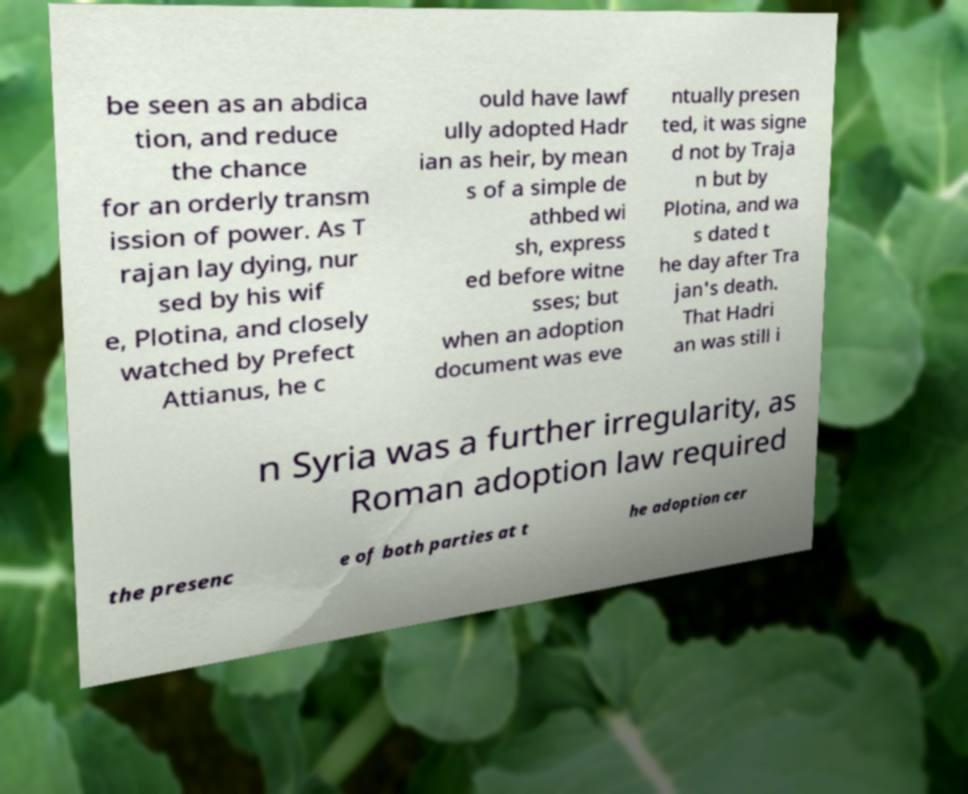Can you accurately transcribe the text from the provided image for me? be seen as an abdica tion, and reduce the chance for an orderly transm ission of power. As T rajan lay dying, nur sed by his wif e, Plotina, and closely watched by Prefect Attianus, he c ould have lawf ully adopted Hadr ian as heir, by mean s of a simple de athbed wi sh, express ed before witne sses; but when an adoption document was eve ntually presen ted, it was signe d not by Traja n but by Plotina, and wa s dated t he day after Tra jan's death. That Hadri an was still i n Syria was a further irregularity, as Roman adoption law required the presenc e of both parties at t he adoption cer 